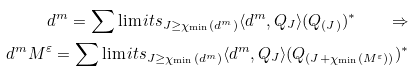<formula> <loc_0><loc_0><loc_500><loc_500>d ^ { m } = \sum \lim i t s _ { J \geq \chi _ { \min } ( d ^ { m } ) } \langle d ^ { m } , Q _ { J } \rangle ( Q _ { ( J ) } ) ^ { \ast } \quad \Rightarrow \\ d ^ { m } M ^ { \varepsilon } = \sum \lim i t s _ { J \geq \chi _ { \min } ( d ^ { m } ) } \langle d ^ { m } , Q _ { J } \rangle ( Q _ { ( J + \chi _ { \min } ( M ^ { \varepsilon } ) ) } ) ^ { \ast }</formula> 